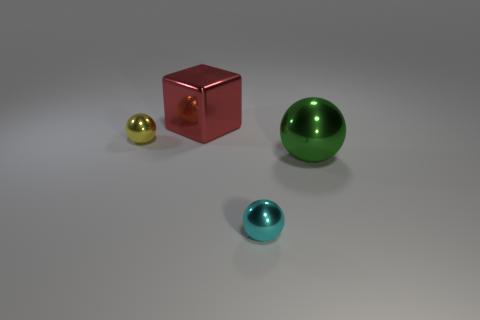What number of cylinders are tiny brown things or small things?
Offer a terse response. 0. What number of things are green shiny balls or tiny spheres behind the cyan thing?
Your answer should be compact. 2. Are any large red rubber blocks visible?
Keep it short and to the point. No. What number of big objects are the same color as the large block?
Keep it short and to the point. 0. There is a thing on the right side of the shiny ball in front of the green shiny object; how big is it?
Keep it short and to the point. Large. Is there another sphere that has the same material as the yellow sphere?
Ensure brevity in your answer.  Yes. There is a green sphere that is the same size as the red cube; what material is it?
Ensure brevity in your answer.  Metal. There is a small metallic object to the left of the red shiny block; is it the same color as the tiny object that is to the right of the tiny yellow shiny object?
Offer a very short reply. No. Are there any tiny cyan spheres that are behind the tiny metallic ball that is to the left of the tiny cyan thing?
Your response must be concise. No. Is the shape of the large metal thing in front of the small yellow metallic object the same as the big thing left of the cyan metallic sphere?
Provide a short and direct response. No. 